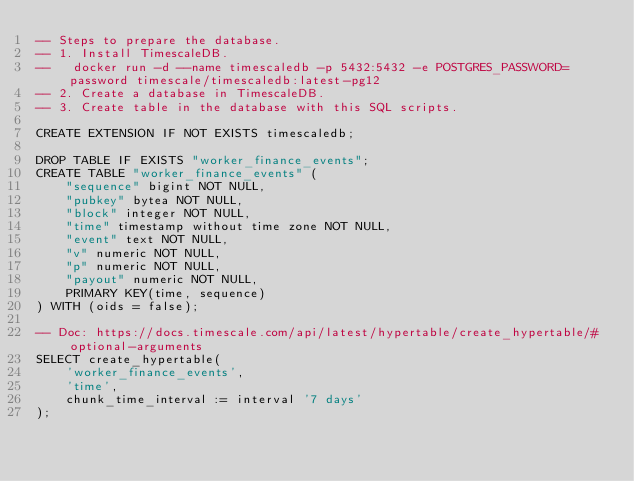Convert code to text. <code><loc_0><loc_0><loc_500><loc_500><_SQL_>-- Steps to prepare the database.
-- 1. Install TimescaleDB.
--   docker run -d --name timescaledb -p 5432:5432 -e POSTGRES_PASSWORD=password timescale/timescaledb:latest-pg12
-- 2. Create a database in TimescaleDB.
-- 3. Create table in the database with this SQL scripts.

CREATE EXTENSION IF NOT EXISTS timescaledb;

DROP TABLE IF EXISTS "worker_finance_events";
CREATE TABLE "worker_finance_events" (
    "sequence" bigint NOT NULL,
    "pubkey" bytea NOT NULL,
    "block" integer NOT NULL,
    "time" timestamp without time zone NOT NULL,
    "event" text NOT NULL,
    "v" numeric NOT NULL,
    "p" numeric NOT NULL,
    "payout" numeric NOT NULL,
    PRIMARY KEY(time, sequence)
) WITH (oids = false);

-- Doc: https://docs.timescale.com/api/latest/hypertable/create_hypertable/#optional-arguments
SELECT create_hypertable(
    'worker_finance_events',
    'time',
    chunk_time_interval := interval '7 days'
);
</code> 